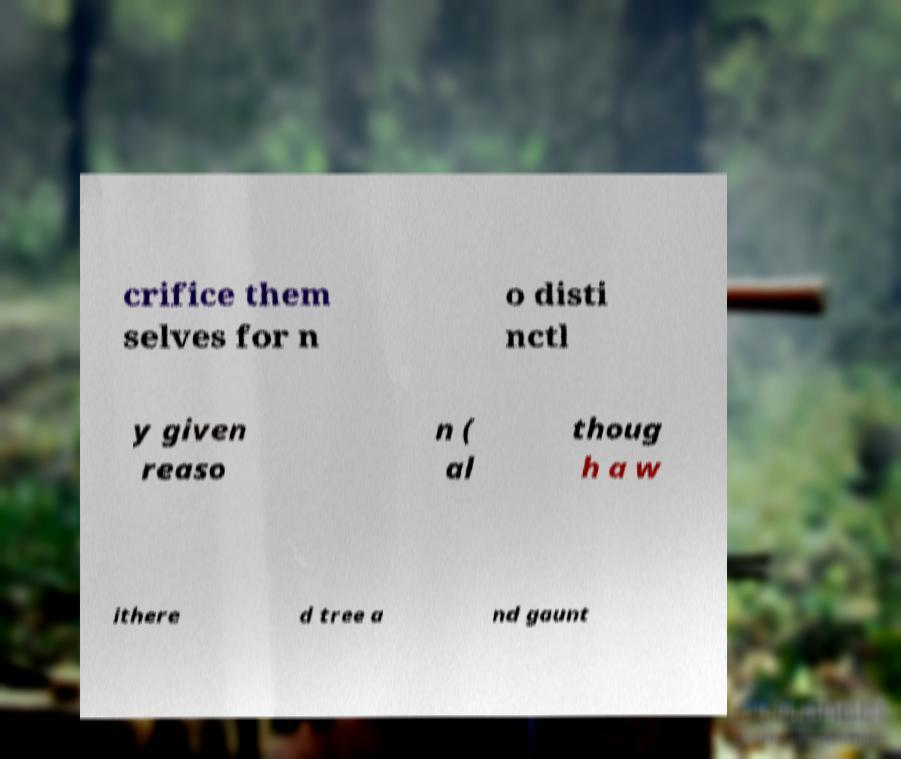There's text embedded in this image that I need extracted. Can you transcribe it verbatim? crifice them selves for n o disti nctl y given reaso n ( al thoug h a w ithere d tree a nd gaunt 